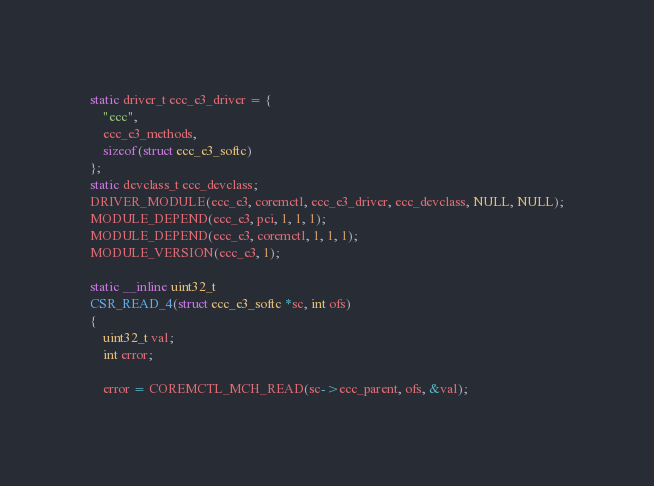Convert code to text. <code><loc_0><loc_0><loc_500><loc_500><_C_>
static driver_t ecc_e3_driver = {
	"ecc",
	ecc_e3_methods,
	sizeof(struct ecc_e3_softc)
};
static devclass_t ecc_devclass;
DRIVER_MODULE(ecc_e3, coremctl, ecc_e3_driver, ecc_devclass, NULL, NULL);
MODULE_DEPEND(ecc_e3, pci, 1, 1, 1);
MODULE_DEPEND(ecc_e3, coremctl, 1, 1, 1);
MODULE_VERSION(ecc_e3, 1);

static __inline uint32_t
CSR_READ_4(struct ecc_e3_softc *sc, int ofs)
{
	uint32_t val;
	int error;

	error = COREMCTL_MCH_READ(sc->ecc_parent, ofs, &val);</code> 